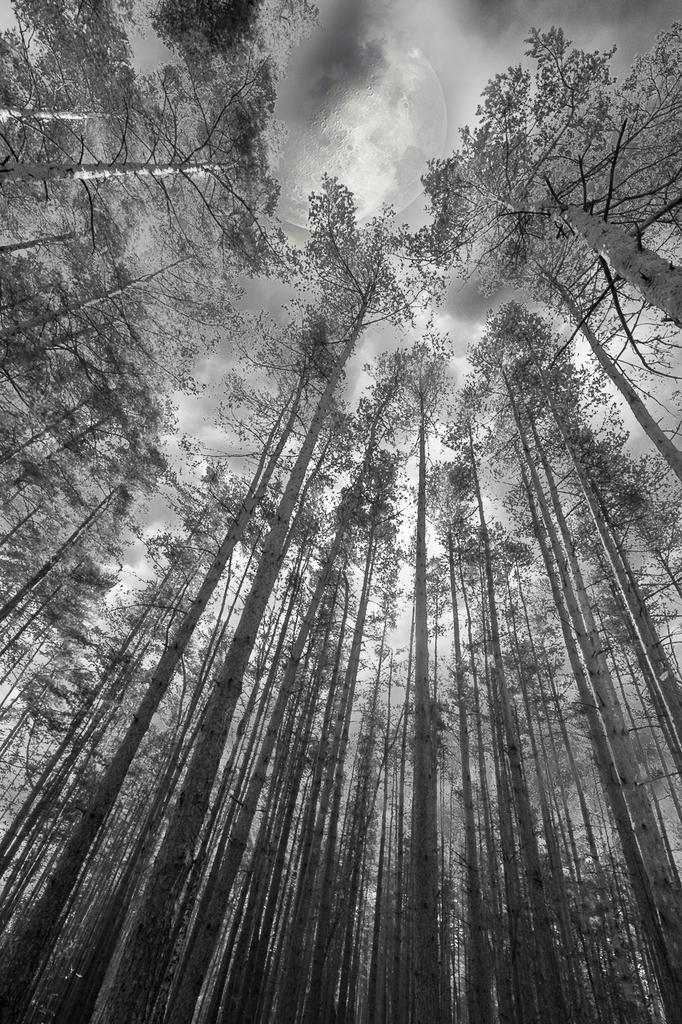Describe this image in one or two sentences. In this picture I can see trees, and in the background there is sky. 